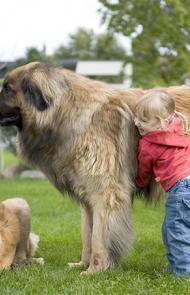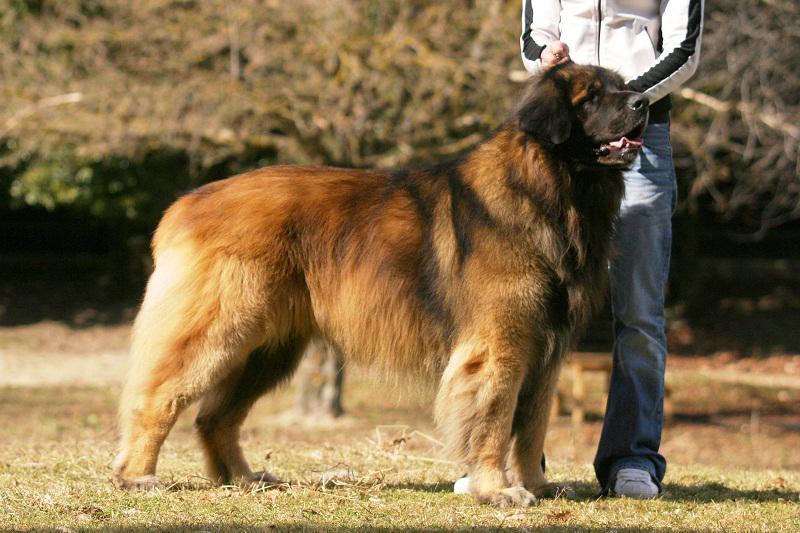The first image is the image on the left, the second image is the image on the right. For the images displayed, is the sentence "there is a child in the image on the left" factually correct? Answer yes or no. Yes. The first image is the image on the left, the second image is the image on the right. Examine the images to the left and right. Is the description "In one image, an adult is standing behind a large dog that has its mouth open." accurate? Answer yes or no. Yes. 